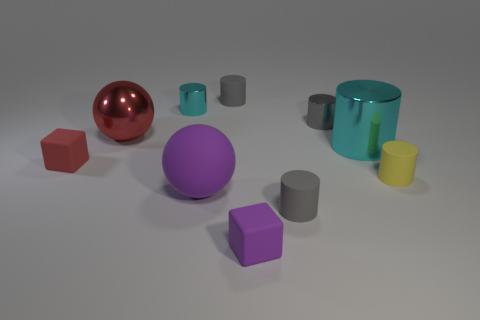How many other objects are there of the same shape as the gray shiny thing?
Your response must be concise. 5. Is there anything else that has the same material as the tiny yellow cylinder?
Make the answer very short. Yes. There is a big metallic object that is to the left of the cyan metal thing that is behind the cyan metallic object that is in front of the large red metal thing; what is its color?
Your answer should be compact. Red. Does the tiny gray matte object that is behind the large rubber object have the same shape as the large purple thing?
Offer a terse response. No. What number of tiny gray objects are there?
Provide a succinct answer. 3. How many gray metallic things are the same size as the red shiny thing?
Your response must be concise. 0. What is the material of the tiny red cube?
Keep it short and to the point. Rubber. Does the big matte object have the same color as the matte block that is in front of the yellow matte cylinder?
Provide a short and direct response. Yes. Are there any other things that have the same size as the yellow matte object?
Your response must be concise. Yes. How big is the matte cylinder that is both behind the large matte object and on the left side of the yellow matte object?
Your answer should be very brief. Small. 